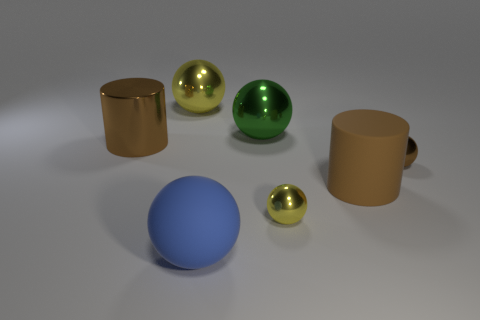What is the shape of the tiny yellow metallic object?
Offer a very short reply. Sphere. Is the number of yellow shiny spheres that are behind the big blue object greater than the number of big brown rubber cylinders that are behind the brown rubber object?
Your answer should be very brief. Yes. There is a cylinder to the right of the green ball; is it the same color as the small object that is behind the tiny yellow object?
Provide a short and direct response. Yes. There is a brown metal object that is the same size as the blue object; what is its shape?
Give a very brief answer. Cylinder. Are there any tiny brown objects of the same shape as the big blue object?
Give a very brief answer. Yes. Do the yellow sphere in front of the tiny brown sphere and the brown cylinder that is behind the rubber cylinder have the same material?
Offer a very short reply. Yes. What shape is the rubber thing that is the same color as the big metal cylinder?
Your answer should be very brief. Cylinder. What number of green balls have the same material as the big blue ball?
Your answer should be compact. 0. The large rubber cylinder has what color?
Your answer should be compact. Brown. Does the matte object that is right of the big blue sphere have the same shape as the small object behind the small yellow thing?
Keep it short and to the point. No. 